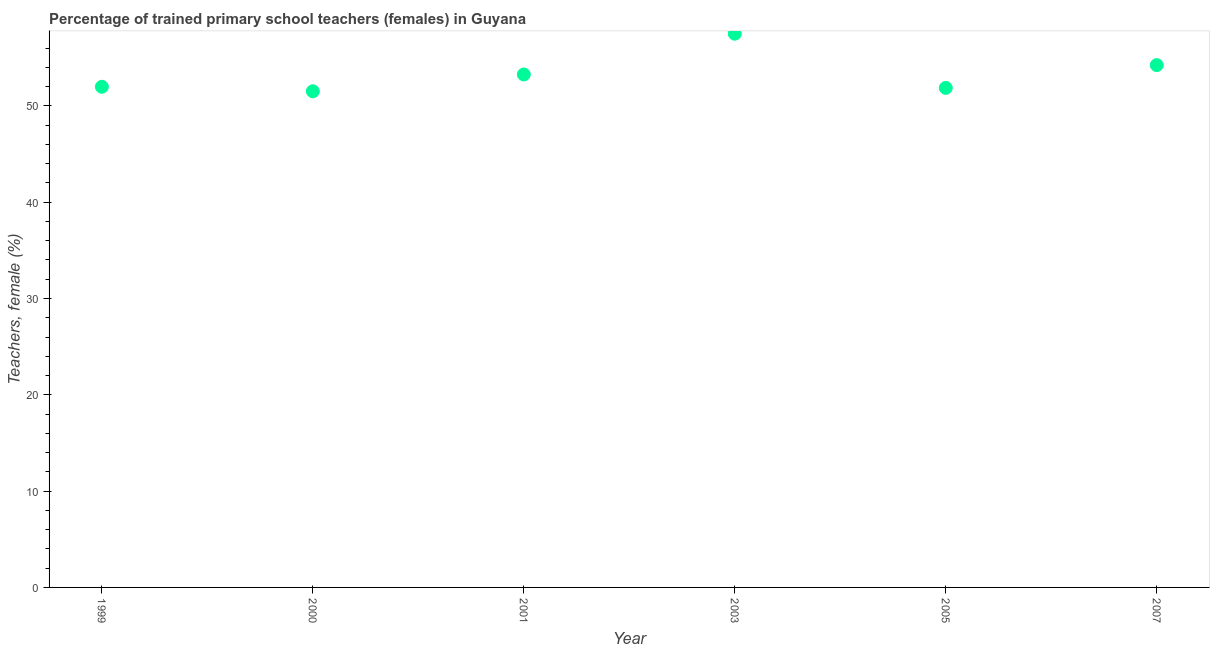What is the percentage of trained female teachers in 2003?
Make the answer very short. 57.49. Across all years, what is the maximum percentage of trained female teachers?
Your answer should be very brief. 57.49. Across all years, what is the minimum percentage of trained female teachers?
Provide a short and direct response. 51.52. What is the sum of the percentage of trained female teachers?
Your answer should be very brief. 320.34. What is the difference between the percentage of trained female teachers in 2003 and 2007?
Offer a terse response. 3.26. What is the average percentage of trained female teachers per year?
Provide a short and direct response. 53.39. What is the median percentage of trained female teachers?
Make the answer very short. 52.62. What is the ratio of the percentage of trained female teachers in 2001 to that in 2005?
Your response must be concise. 1.03. Is the percentage of trained female teachers in 1999 less than that in 2000?
Offer a very short reply. No. Is the difference between the percentage of trained female teachers in 2001 and 2005 greater than the difference between any two years?
Make the answer very short. No. What is the difference between the highest and the second highest percentage of trained female teachers?
Your answer should be compact. 3.26. Is the sum of the percentage of trained female teachers in 1999 and 2003 greater than the maximum percentage of trained female teachers across all years?
Give a very brief answer. Yes. What is the difference between the highest and the lowest percentage of trained female teachers?
Provide a short and direct response. 5.98. In how many years, is the percentage of trained female teachers greater than the average percentage of trained female teachers taken over all years?
Provide a succinct answer. 2. Does the graph contain any zero values?
Offer a very short reply. No. What is the title of the graph?
Make the answer very short. Percentage of trained primary school teachers (females) in Guyana. What is the label or title of the X-axis?
Make the answer very short. Year. What is the label or title of the Y-axis?
Your response must be concise. Teachers, female (%). What is the Teachers, female (%) in 1999?
Your answer should be very brief. 51.98. What is the Teachers, female (%) in 2000?
Ensure brevity in your answer.  51.52. What is the Teachers, female (%) in 2001?
Your answer should be compact. 53.26. What is the Teachers, female (%) in 2003?
Offer a terse response. 57.49. What is the Teachers, female (%) in 2005?
Provide a short and direct response. 51.87. What is the Teachers, female (%) in 2007?
Make the answer very short. 54.23. What is the difference between the Teachers, female (%) in 1999 and 2000?
Provide a succinct answer. 0.46. What is the difference between the Teachers, female (%) in 1999 and 2001?
Your response must be concise. -1.28. What is the difference between the Teachers, female (%) in 1999 and 2003?
Offer a very short reply. -5.51. What is the difference between the Teachers, female (%) in 1999 and 2005?
Provide a short and direct response. 0.11. What is the difference between the Teachers, female (%) in 1999 and 2007?
Give a very brief answer. -2.25. What is the difference between the Teachers, female (%) in 2000 and 2001?
Give a very brief answer. -1.74. What is the difference between the Teachers, female (%) in 2000 and 2003?
Offer a terse response. -5.98. What is the difference between the Teachers, female (%) in 2000 and 2005?
Ensure brevity in your answer.  -0.35. What is the difference between the Teachers, female (%) in 2000 and 2007?
Your response must be concise. -2.72. What is the difference between the Teachers, female (%) in 2001 and 2003?
Your answer should be compact. -4.23. What is the difference between the Teachers, female (%) in 2001 and 2005?
Your response must be concise. 1.39. What is the difference between the Teachers, female (%) in 2001 and 2007?
Your response must be concise. -0.97. What is the difference between the Teachers, female (%) in 2003 and 2005?
Keep it short and to the point. 5.63. What is the difference between the Teachers, female (%) in 2003 and 2007?
Offer a very short reply. 3.26. What is the difference between the Teachers, female (%) in 2005 and 2007?
Provide a succinct answer. -2.37. What is the ratio of the Teachers, female (%) in 1999 to that in 2001?
Your answer should be compact. 0.98. What is the ratio of the Teachers, female (%) in 1999 to that in 2003?
Keep it short and to the point. 0.9. What is the ratio of the Teachers, female (%) in 1999 to that in 2005?
Ensure brevity in your answer.  1. What is the ratio of the Teachers, female (%) in 1999 to that in 2007?
Your answer should be compact. 0.96. What is the ratio of the Teachers, female (%) in 2000 to that in 2003?
Offer a very short reply. 0.9. What is the ratio of the Teachers, female (%) in 2000 to that in 2005?
Make the answer very short. 0.99. What is the ratio of the Teachers, female (%) in 2001 to that in 2003?
Provide a short and direct response. 0.93. What is the ratio of the Teachers, female (%) in 2003 to that in 2005?
Provide a short and direct response. 1.11. What is the ratio of the Teachers, female (%) in 2003 to that in 2007?
Your response must be concise. 1.06. What is the ratio of the Teachers, female (%) in 2005 to that in 2007?
Make the answer very short. 0.96. 